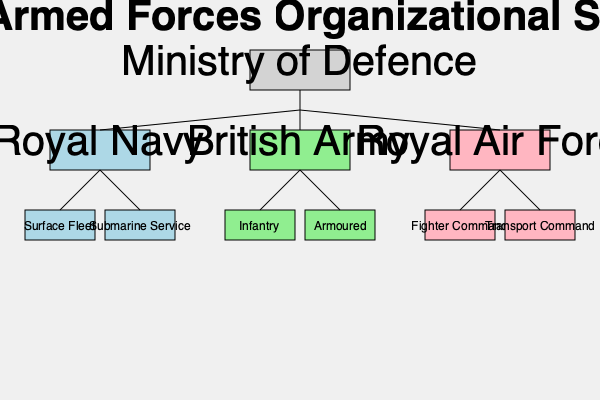Based on the organizational structure shown in the hierarchical chart, which branch of the British Armed Forces would have been primarily responsible for maritime operations during the Troubles, and what are its two main sub-branches? To answer this question, we need to analyze the hierarchical chart of the British Armed Forces organizational structure:

1. The chart shows three main branches under the Ministry of Defence:
   - Royal Navy
   - British Army
   - Royal Air Force

2. Each of these branches has two sub-branches displayed.

3. For maritime operations, we need to focus on the branch responsible for naval activities.

4. The Royal Navy is the branch of the Armed Forces dedicated to maritime operations.

5. Under the Royal Navy, we can see two sub-branches:
   - Surface Fleet
   - Submarine Service

6. These two sub-branches represent the main components of the Royal Navy's operational capabilities.

7. During the Troubles, the Royal Navy would have been responsible for any maritime operations required, such as patrolling waters around Northern Ireland, providing support for amphibious operations, or conducting maritime interdiction operations.

Therefore, the Royal Navy was the branch primarily responsible for maritime operations during the Troubles, with its two main sub-branches being the Surface Fleet and Submarine Service.
Answer: Royal Navy; Surface Fleet and Submarine Service 